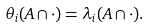<formula> <loc_0><loc_0><loc_500><loc_500>\theta _ { i } ( A \cap \cdot ) = \lambda _ { i } ( A \cap \cdot ) .</formula> 